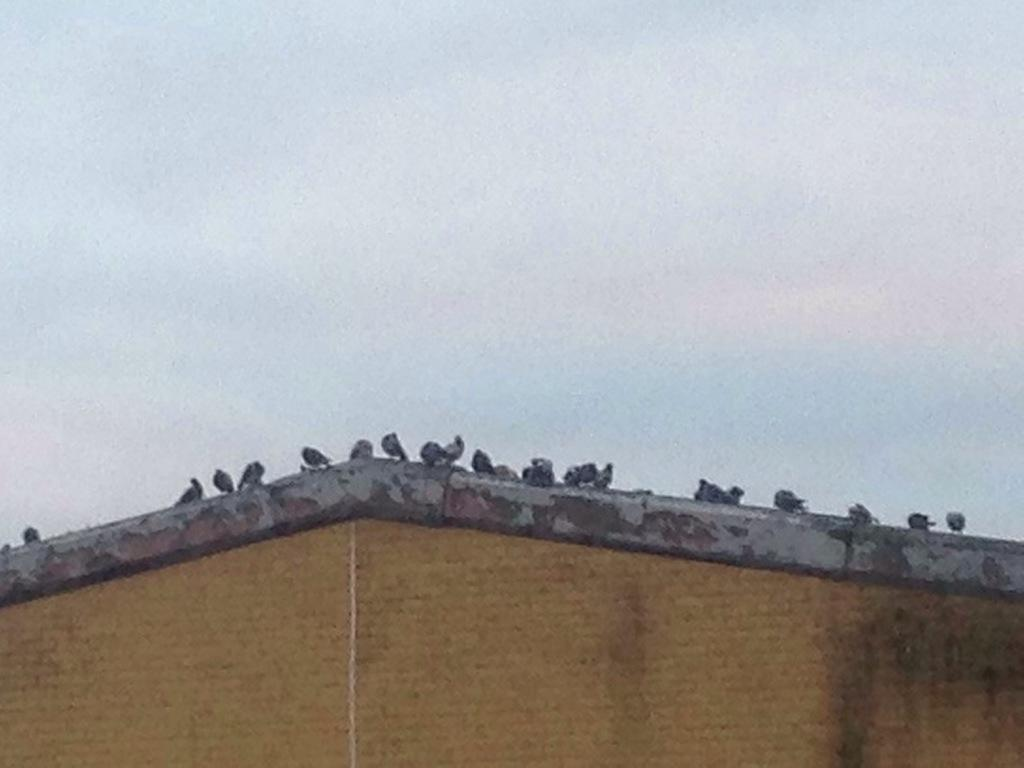What animals are on the wall in the image? There are birds on a wall in the image. What part of the natural environment is visible in the image? The sky is visible at the top of the image. What type of wound can be seen on the library in the image? There is no library or wound present in the image; it features birds on a wall and the sky. 